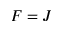<formula> <loc_0><loc_0><loc_500><loc_500>F = J</formula> 